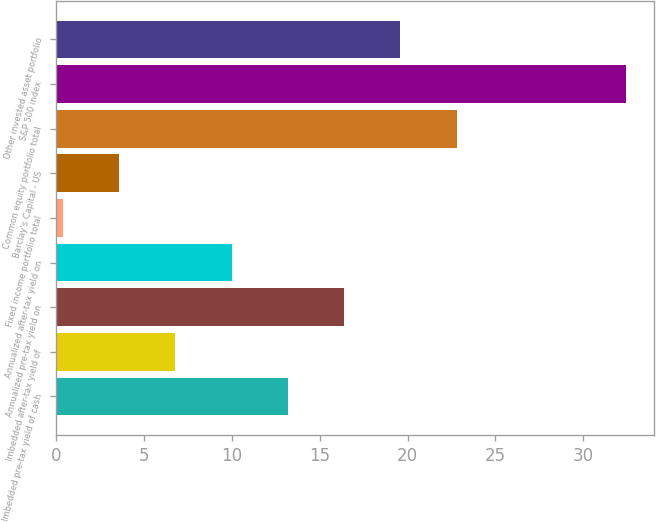<chart> <loc_0><loc_0><loc_500><loc_500><bar_chart><fcel>Imbedded pre-tax yield of cash<fcel>Imbedded after-tax yield of<fcel>Annualized pre-tax yield on<fcel>Annualized after-tax yield on<fcel>Fixed income portfolio total<fcel>Barclay's Capital - US<fcel>Common equity portfolio total<fcel>S&P 500 index<fcel>Other invested asset portfolio<nl><fcel>13.2<fcel>6.8<fcel>16.4<fcel>10<fcel>0.4<fcel>3.6<fcel>22.8<fcel>32.4<fcel>19.6<nl></chart> 